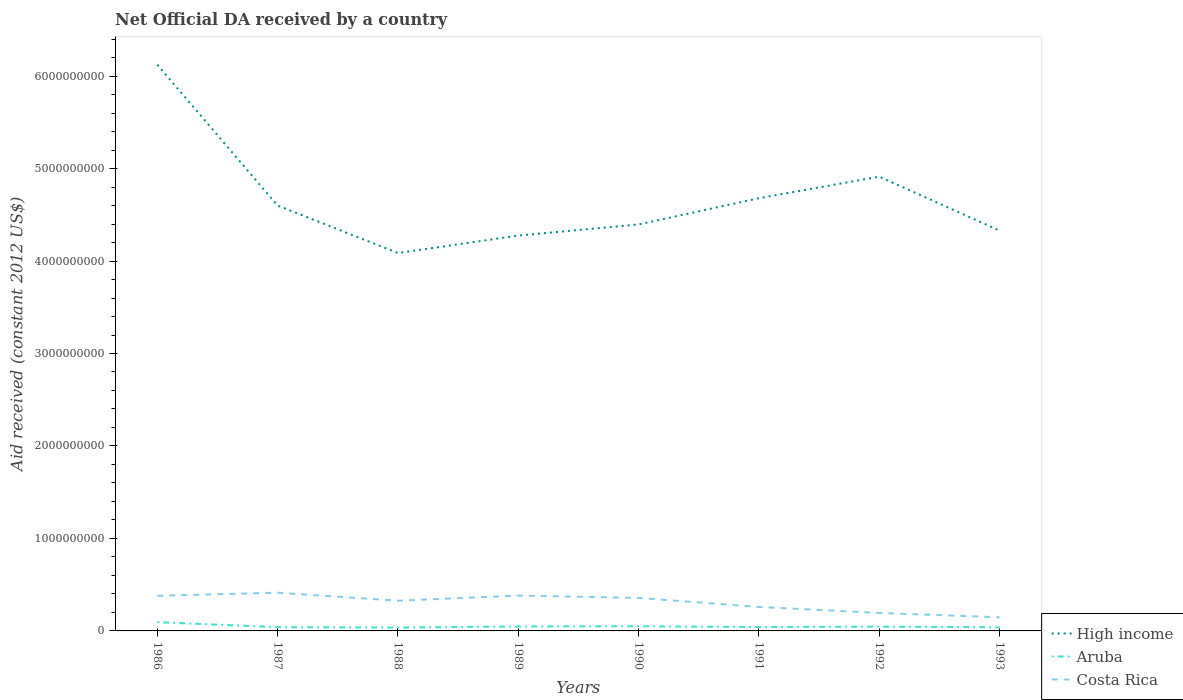Across all years, what is the maximum net official development assistance aid received in High income?
Your response must be concise. 4.09e+09. What is the total net official development assistance aid received in High income in the graph?
Give a very brief answer. 2.04e+09. What is the difference between the highest and the second highest net official development assistance aid received in Aruba?
Make the answer very short. 5.84e+07. What is the difference between the highest and the lowest net official development assistance aid received in Costa Rica?
Provide a succinct answer. 5. Is the net official development assistance aid received in Aruba strictly greater than the net official development assistance aid received in Costa Rica over the years?
Offer a terse response. Yes. How many years are there in the graph?
Ensure brevity in your answer.  8. Are the values on the major ticks of Y-axis written in scientific E-notation?
Your answer should be very brief. No. Does the graph contain any zero values?
Give a very brief answer. No. How many legend labels are there?
Offer a terse response. 3. How are the legend labels stacked?
Make the answer very short. Vertical. What is the title of the graph?
Your answer should be very brief. Net Official DA received by a country. Does "Oman" appear as one of the legend labels in the graph?
Keep it short and to the point. No. What is the label or title of the X-axis?
Make the answer very short. Years. What is the label or title of the Y-axis?
Offer a very short reply. Aid received (constant 2012 US$). What is the Aid received (constant 2012 US$) in High income in 1986?
Offer a terse response. 6.12e+09. What is the Aid received (constant 2012 US$) of Aruba in 1986?
Your answer should be very brief. 9.46e+07. What is the Aid received (constant 2012 US$) of Costa Rica in 1986?
Ensure brevity in your answer.  3.80e+08. What is the Aid received (constant 2012 US$) of High income in 1987?
Offer a terse response. 4.60e+09. What is the Aid received (constant 2012 US$) of Aruba in 1987?
Provide a short and direct response. 4.08e+07. What is the Aid received (constant 2012 US$) in Costa Rica in 1987?
Keep it short and to the point. 4.14e+08. What is the Aid received (constant 2012 US$) in High income in 1988?
Keep it short and to the point. 4.09e+09. What is the Aid received (constant 2012 US$) in Aruba in 1988?
Your answer should be compact. 3.62e+07. What is the Aid received (constant 2012 US$) in Costa Rica in 1988?
Your answer should be compact. 3.27e+08. What is the Aid received (constant 2012 US$) in High income in 1989?
Offer a terse response. 4.28e+09. What is the Aid received (constant 2012 US$) in Aruba in 1989?
Your answer should be compact. 4.83e+07. What is the Aid received (constant 2012 US$) in Costa Rica in 1989?
Your answer should be compact. 3.82e+08. What is the Aid received (constant 2012 US$) of High income in 1990?
Give a very brief answer. 4.40e+09. What is the Aid received (constant 2012 US$) in Aruba in 1990?
Your answer should be very brief. 5.03e+07. What is the Aid received (constant 2012 US$) of Costa Rica in 1990?
Your response must be concise. 3.57e+08. What is the Aid received (constant 2012 US$) in High income in 1991?
Keep it short and to the point. 4.68e+09. What is the Aid received (constant 2012 US$) in Aruba in 1991?
Offer a terse response. 4.18e+07. What is the Aid received (constant 2012 US$) of Costa Rica in 1991?
Your answer should be compact. 2.59e+08. What is the Aid received (constant 2012 US$) in High income in 1992?
Ensure brevity in your answer.  4.91e+09. What is the Aid received (constant 2012 US$) in Aruba in 1992?
Your response must be concise. 4.60e+07. What is the Aid received (constant 2012 US$) in Costa Rica in 1992?
Your response must be concise. 1.95e+08. What is the Aid received (constant 2012 US$) of High income in 1993?
Provide a succinct answer. 4.33e+09. What is the Aid received (constant 2012 US$) in Aruba in 1993?
Your response must be concise. 3.96e+07. What is the Aid received (constant 2012 US$) of Costa Rica in 1993?
Keep it short and to the point. 1.48e+08. Across all years, what is the maximum Aid received (constant 2012 US$) in High income?
Provide a short and direct response. 6.12e+09. Across all years, what is the maximum Aid received (constant 2012 US$) in Aruba?
Make the answer very short. 9.46e+07. Across all years, what is the maximum Aid received (constant 2012 US$) in Costa Rica?
Provide a succinct answer. 4.14e+08. Across all years, what is the minimum Aid received (constant 2012 US$) in High income?
Your answer should be compact. 4.09e+09. Across all years, what is the minimum Aid received (constant 2012 US$) in Aruba?
Offer a terse response. 3.62e+07. Across all years, what is the minimum Aid received (constant 2012 US$) in Costa Rica?
Make the answer very short. 1.48e+08. What is the total Aid received (constant 2012 US$) in High income in the graph?
Your answer should be compact. 3.74e+1. What is the total Aid received (constant 2012 US$) of Aruba in the graph?
Keep it short and to the point. 3.97e+08. What is the total Aid received (constant 2012 US$) in Costa Rica in the graph?
Your answer should be very brief. 2.46e+09. What is the difference between the Aid received (constant 2012 US$) in High income in 1986 and that in 1987?
Ensure brevity in your answer.  1.52e+09. What is the difference between the Aid received (constant 2012 US$) in Aruba in 1986 and that in 1987?
Your response must be concise. 5.39e+07. What is the difference between the Aid received (constant 2012 US$) of Costa Rica in 1986 and that in 1987?
Your answer should be compact. -3.40e+07. What is the difference between the Aid received (constant 2012 US$) of High income in 1986 and that in 1988?
Give a very brief answer. 2.04e+09. What is the difference between the Aid received (constant 2012 US$) in Aruba in 1986 and that in 1988?
Provide a short and direct response. 5.84e+07. What is the difference between the Aid received (constant 2012 US$) in Costa Rica in 1986 and that in 1988?
Your answer should be very brief. 5.31e+07. What is the difference between the Aid received (constant 2012 US$) in High income in 1986 and that in 1989?
Your response must be concise. 1.85e+09. What is the difference between the Aid received (constant 2012 US$) in Aruba in 1986 and that in 1989?
Your response must be concise. 4.63e+07. What is the difference between the Aid received (constant 2012 US$) of Costa Rica in 1986 and that in 1989?
Offer a very short reply. -2.80e+06. What is the difference between the Aid received (constant 2012 US$) in High income in 1986 and that in 1990?
Ensure brevity in your answer.  1.73e+09. What is the difference between the Aid received (constant 2012 US$) of Aruba in 1986 and that in 1990?
Keep it short and to the point. 4.43e+07. What is the difference between the Aid received (constant 2012 US$) in Costa Rica in 1986 and that in 1990?
Offer a very short reply. 2.28e+07. What is the difference between the Aid received (constant 2012 US$) in High income in 1986 and that in 1991?
Provide a short and direct response. 1.44e+09. What is the difference between the Aid received (constant 2012 US$) in Aruba in 1986 and that in 1991?
Give a very brief answer. 5.29e+07. What is the difference between the Aid received (constant 2012 US$) of Costa Rica in 1986 and that in 1991?
Ensure brevity in your answer.  1.21e+08. What is the difference between the Aid received (constant 2012 US$) in High income in 1986 and that in 1992?
Give a very brief answer. 1.21e+09. What is the difference between the Aid received (constant 2012 US$) of Aruba in 1986 and that in 1992?
Your answer should be compact. 4.86e+07. What is the difference between the Aid received (constant 2012 US$) of Costa Rica in 1986 and that in 1992?
Make the answer very short. 1.85e+08. What is the difference between the Aid received (constant 2012 US$) in High income in 1986 and that in 1993?
Provide a short and direct response. 1.79e+09. What is the difference between the Aid received (constant 2012 US$) in Aruba in 1986 and that in 1993?
Provide a succinct answer. 5.51e+07. What is the difference between the Aid received (constant 2012 US$) of Costa Rica in 1986 and that in 1993?
Provide a succinct answer. 2.32e+08. What is the difference between the Aid received (constant 2012 US$) of High income in 1987 and that in 1988?
Give a very brief answer. 5.14e+08. What is the difference between the Aid received (constant 2012 US$) in Aruba in 1987 and that in 1988?
Provide a succinct answer. 4.54e+06. What is the difference between the Aid received (constant 2012 US$) of Costa Rica in 1987 and that in 1988?
Your response must be concise. 8.71e+07. What is the difference between the Aid received (constant 2012 US$) of High income in 1987 and that in 1989?
Keep it short and to the point. 3.25e+08. What is the difference between the Aid received (constant 2012 US$) of Aruba in 1987 and that in 1989?
Offer a terse response. -7.56e+06. What is the difference between the Aid received (constant 2012 US$) of Costa Rica in 1987 and that in 1989?
Keep it short and to the point. 3.12e+07. What is the difference between the Aid received (constant 2012 US$) in High income in 1987 and that in 1990?
Keep it short and to the point. 2.04e+08. What is the difference between the Aid received (constant 2012 US$) in Aruba in 1987 and that in 1990?
Provide a short and direct response. -9.53e+06. What is the difference between the Aid received (constant 2012 US$) in Costa Rica in 1987 and that in 1990?
Make the answer very short. 5.68e+07. What is the difference between the Aid received (constant 2012 US$) of High income in 1987 and that in 1991?
Your response must be concise. -7.94e+07. What is the difference between the Aid received (constant 2012 US$) of Aruba in 1987 and that in 1991?
Offer a terse response. -1.01e+06. What is the difference between the Aid received (constant 2012 US$) of Costa Rica in 1987 and that in 1991?
Your answer should be very brief. 1.55e+08. What is the difference between the Aid received (constant 2012 US$) in High income in 1987 and that in 1992?
Give a very brief answer. -3.12e+08. What is the difference between the Aid received (constant 2012 US$) of Aruba in 1987 and that in 1992?
Keep it short and to the point. -5.25e+06. What is the difference between the Aid received (constant 2012 US$) of Costa Rica in 1987 and that in 1992?
Offer a terse response. 2.19e+08. What is the difference between the Aid received (constant 2012 US$) in High income in 1987 and that in 1993?
Provide a succinct answer. 2.70e+08. What is the difference between the Aid received (constant 2012 US$) in Aruba in 1987 and that in 1993?
Provide a short and direct response. 1.20e+06. What is the difference between the Aid received (constant 2012 US$) in Costa Rica in 1987 and that in 1993?
Make the answer very short. 2.66e+08. What is the difference between the Aid received (constant 2012 US$) in High income in 1988 and that in 1989?
Keep it short and to the point. -1.89e+08. What is the difference between the Aid received (constant 2012 US$) in Aruba in 1988 and that in 1989?
Ensure brevity in your answer.  -1.21e+07. What is the difference between the Aid received (constant 2012 US$) of Costa Rica in 1988 and that in 1989?
Provide a succinct answer. -5.59e+07. What is the difference between the Aid received (constant 2012 US$) of High income in 1988 and that in 1990?
Ensure brevity in your answer.  -3.09e+08. What is the difference between the Aid received (constant 2012 US$) of Aruba in 1988 and that in 1990?
Give a very brief answer. -1.41e+07. What is the difference between the Aid received (constant 2012 US$) in Costa Rica in 1988 and that in 1990?
Your answer should be very brief. -3.03e+07. What is the difference between the Aid received (constant 2012 US$) in High income in 1988 and that in 1991?
Offer a very short reply. -5.93e+08. What is the difference between the Aid received (constant 2012 US$) of Aruba in 1988 and that in 1991?
Keep it short and to the point. -5.55e+06. What is the difference between the Aid received (constant 2012 US$) in Costa Rica in 1988 and that in 1991?
Offer a terse response. 6.74e+07. What is the difference between the Aid received (constant 2012 US$) in High income in 1988 and that in 1992?
Ensure brevity in your answer.  -8.26e+08. What is the difference between the Aid received (constant 2012 US$) of Aruba in 1988 and that in 1992?
Give a very brief answer. -9.79e+06. What is the difference between the Aid received (constant 2012 US$) of Costa Rica in 1988 and that in 1992?
Your answer should be very brief. 1.32e+08. What is the difference between the Aid received (constant 2012 US$) of High income in 1988 and that in 1993?
Make the answer very short. -2.43e+08. What is the difference between the Aid received (constant 2012 US$) of Aruba in 1988 and that in 1993?
Your answer should be compact. -3.34e+06. What is the difference between the Aid received (constant 2012 US$) of Costa Rica in 1988 and that in 1993?
Provide a short and direct response. 1.79e+08. What is the difference between the Aid received (constant 2012 US$) in High income in 1989 and that in 1990?
Your response must be concise. -1.20e+08. What is the difference between the Aid received (constant 2012 US$) of Aruba in 1989 and that in 1990?
Give a very brief answer. -1.97e+06. What is the difference between the Aid received (constant 2012 US$) of Costa Rica in 1989 and that in 1990?
Offer a terse response. 2.56e+07. What is the difference between the Aid received (constant 2012 US$) of High income in 1989 and that in 1991?
Keep it short and to the point. -4.04e+08. What is the difference between the Aid received (constant 2012 US$) of Aruba in 1989 and that in 1991?
Your answer should be very brief. 6.55e+06. What is the difference between the Aid received (constant 2012 US$) in Costa Rica in 1989 and that in 1991?
Keep it short and to the point. 1.23e+08. What is the difference between the Aid received (constant 2012 US$) of High income in 1989 and that in 1992?
Ensure brevity in your answer.  -6.37e+08. What is the difference between the Aid received (constant 2012 US$) in Aruba in 1989 and that in 1992?
Keep it short and to the point. 2.31e+06. What is the difference between the Aid received (constant 2012 US$) of Costa Rica in 1989 and that in 1992?
Offer a very short reply. 1.88e+08. What is the difference between the Aid received (constant 2012 US$) in High income in 1989 and that in 1993?
Offer a very short reply. -5.44e+07. What is the difference between the Aid received (constant 2012 US$) in Aruba in 1989 and that in 1993?
Your answer should be very brief. 8.76e+06. What is the difference between the Aid received (constant 2012 US$) in Costa Rica in 1989 and that in 1993?
Offer a very short reply. 2.35e+08. What is the difference between the Aid received (constant 2012 US$) in High income in 1990 and that in 1991?
Give a very brief answer. -2.84e+08. What is the difference between the Aid received (constant 2012 US$) of Aruba in 1990 and that in 1991?
Your answer should be compact. 8.52e+06. What is the difference between the Aid received (constant 2012 US$) in Costa Rica in 1990 and that in 1991?
Your response must be concise. 9.77e+07. What is the difference between the Aid received (constant 2012 US$) in High income in 1990 and that in 1992?
Your answer should be very brief. -5.17e+08. What is the difference between the Aid received (constant 2012 US$) of Aruba in 1990 and that in 1992?
Give a very brief answer. 4.28e+06. What is the difference between the Aid received (constant 2012 US$) of Costa Rica in 1990 and that in 1992?
Ensure brevity in your answer.  1.62e+08. What is the difference between the Aid received (constant 2012 US$) in High income in 1990 and that in 1993?
Your answer should be compact. 6.60e+07. What is the difference between the Aid received (constant 2012 US$) of Aruba in 1990 and that in 1993?
Provide a short and direct response. 1.07e+07. What is the difference between the Aid received (constant 2012 US$) of Costa Rica in 1990 and that in 1993?
Your response must be concise. 2.09e+08. What is the difference between the Aid received (constant 2012 US$) in High income in 1991 and that in 1992?
Provide a short and direct response. -2.33e+08. What is the difference between the Aid received (constant 2012 US$) in Aruba in 1991 and that in 1992?
Offer a very short reply. -4.24e+06. What is the difference between the Aid received (constant 2012 US$) in Costa Rica in 1991 and that in 1992?
Ensure brevity in your answer.  6.46e+07. What is the difference between the Aid received (constant 2012 US$) of High income in 1991 and that in 1993?
Offer a very short reply. 3.50e+08. What is the difference between the Aid received (constant 2012 US$) of Aruba in 1991 and that in 1993?
Your answer should be compact. 2.21e+06. What is the difference between the Aid received (constant 2012 US$) of Costa Rica in 1991 and that in 1993?
Provide a short and direct response. 1.12e+08. What is the difference between the Aid received (constant 2012 US$) in High income in 1992 and that in 1993?
Your response must be concise. 5.83e+08. What is the difference between the Aid received (constant 2012 US$) of Aruba in 1992 and that in 1993?
Ensure brevity in your answer.  6.45e+06. What is the difference between the Aid received (constant 2012 US$) of Costa Rica in 1992 and that in 1993?
Ensure brevity in your answer.  4.70e+07. What is the difference between the Aid received (constant 2012 US$) in High income in 1986 and the Aid received (constant 2012 US$) in Aruba in 1987?
Your answer should be compact. 6.08e+09. What is the difference between the Aid received (constant 2012 US$) of High income in 1986 and the Aid received (constant 2012 US$) of Costa Rica in 1987?
Keep it short and to the point. 5.71e+09. What is the difference between the Aid received (constant 2012 US$) in Aruba in 1986 and the Aid received (constant 2012 US$) in Costa Rica in 1987?
Your response must be concise. -3.19e+08. What is the difference between the Aid received (constant 2012 US$) in High income in 1986 and the Aid received (constant 2012 US$) in Aruba in 1988?
Give a very brief answer. 6.09e+09. What is the difference between the Aid received (constant 2012 US$) in High income in 1986 and the Aid received (constant 2012 US$) in Costa Rica in 1988?
Ensure brevity in your answer.  5.80e+09. What is the difference between the Aid received (constant 2012 US$) of Aruba in 1986 and the Aid received (constant 2012 US$) of Costa Rica in 1988?
Offer a terse response. -2.32e+08. What is the difference between the Aid received (constant 2012 US$) in High income in 1986 and the Aid received (constant 2012 US$) in Aruba in 1989?
Provide a short and direct response. 6.07e+09. What is the difference between the Aid received (constant 2012 US$) in High income in 1986 and the Aid received (constant 2012 US$) in Costa Rica in 1989?
Ensure brevity in your answer.  5.74e+09. What is the difference between the Aid received (constant 2012 US$) in Aruba in 1986 and the Aid received (constant 2012 US$) in Costa Rica in 1989?
Offer a very short reply. -2.88e+08. What is the difference between the Aid received (constant 2012 US$) of High income in 1986 and the Aid received (constant 2012 US$) of Aruba in 1990?
Your response must be concise. 6.07e+09. What is the difference between the Aid received (constant 2012 US$) of High income in 1986 and the Aid received (constant 2012 US$) of Costa Rica in 1990?
Your answer should be compact. 5.77e+09. What is the difference between the Aid received (constant 2012 US$) in Aruba in 1986 and the Aid received (constant 2012 US$) in Costa Rica in 1990?
Your response must be concise. -2.62e+08. What is the difference between the Aid received (constant 2012 US$) in High income in 1986 and the Aid received (constant 2012 US$) in Aruba in 1991?
Make the answer very short. 6.08e+09. What is the difference between the Aid received (constant 2012 US$) of High income in 1986 and the Aid received (constant 2012 US$) of Costa Rica in 1991?
Give a very brief answer. 5.86e+09. What is the difference between the Aid received (constant 2012 US$) of Aruba in 1986 and the Aid received (constant 2012 US$) of Costa Rica in 1991?
Provide a short and direct response. -1.64e+08. What is the difference between the Aid received (constant 2012 US$) in High income in 1986 and the Aid received (constant 2012 US$) in Aruba in 1992?
Your answer should be very brief. 6.08e+09. What is the difference between the Aid received (constant 2012 US$) in High income in 1986 and the Aid received (constant 2012 US$) in Costa Rica in 1992?
Provide a short and direct response. 5.93e+09. What is the difference between the Aid received (constant 2012 US$) of Aruba in 1986 and the Aid received (constant 2012 US$) of Costa Rica in 1992?
Offer a very short reply. -9.99e+07. What is the difference between the Aid received (constant 2012 US$) in High income in 1986 and the Aid received (constant 2012 US$) in Aruba in 1993?
Your answer should be compact. 6.08e+09. What is the difference between the Aid received (constant 2012 US$) of High income in 1986 and the Aid received (constant 2012 US$) of Costa Rica in 1993?
Your response must be concise. 5.98e+09. What is the difference between the Aid received (constant 2012 US$) of Aruba in 1986 and the Aid received (constant 2012 US$) of Costa Rica in 1993?
Provide a short and direct response. -5.29e+07. What is the difference between the Aid received (constant 2012 US$) of High income in 1987 and the Aid received (constant 2012 US$) of Aruba in 1988?
Make the answer very short. 4.56e+09. What is the difference between the Aid received (constant 2012 US$) of High income in 1987 and the Aid received (constant 2012 US$) of Costa Rica in 1988?
Your response must be concise. 4.27e+09. What is the difference between the Aid received (constant 2012 US$) of Aruba in 1987 and the Aid received (constant 2012 US$) of Costa Rica in 1988?
Your response must be concise. -2.86e+08. What is the difference between the Aid received (constant 2012 US$) in High income in 1987 and the Aid received (constant 2012 US$) in Aruba in 1989?
Provide a succinct answer. 4.55e+09. What is the difference between the Aid received (constant 2012 US$) of High income in 1987 and the Aid received (constant 2012 US$) of Costa Rica in 1989?
Offer a terse response. 4.22e+09. What is the difference between the Aid received (constant 2012 US$) in Aruba in 1987 and the Aid received (constant 2012 US$) in Costa Rica in 1989?
Offer a very short reply. -3.42e+08. What is the difference between the Aid received (constant 2012 US$) of High income in 1987 and the Aid received (constant 2012 US$) of Aruba in 1990?
Provide a short and direct response. 4.55e+09. What is the difference between the Aid received (constant 2012 US$) in High income in 1987 and the Aid received (constant 2012 US$) in Costa Rica in 1990?
Ensure brevity in your answer.  4.24e+09. What is the difference between the Aid received (constant 2012 US$) in Aruba in 1987 and the Aid received (constant 2012 US$) in Costa Rica in 1990?
Keep it short and to the point. -3.16e+08. What is the difference between the Aid received (constant 2012 US$) of High income in 1987 and the Aid received (constant 2012 US$) of Aruba in 1991?
Ensure brevity in your answer.  4.56e+09. What is the difference between the Aid received (constant 2012 US$) of High income in 1987 and the Aid received (constant 2012 US$) of Costa Rica in 1991?
Your response must be concise. 4.34e+09. What is the difference between the Aid received (constant 2012 US$) in Aruba in 1987 and the Aid received (constant 2012 US$) in Costa Rica in 1991?
Ensure brevity in your answer.  -2.18e+08. What is the difference between the Aid received (constant 2012 US$) in High income in 1987 and the Aid received (constant 2012 US$) in Aruba in 1992?
Provide a short and direct response. 4.55e+09. What is the difference between the Aid received (constant 2012 US$) in High income in 1987 and the Aid received (constant 2012 US$) in Costa Rica in 1992?
Your response must be concise. 4.41e+09. What is the difference between the Aid received (constant 2012 US$) of Aruba in 1987 and the Aid received (constant 2012 US$) of Costa Rica in 1992?
Your response must be concise. -1.54e+08. What is the difference between the Aid received (constant 2012 US$) of High income in 1987 and the Aid received (constant 2012 US$) of Aruba in 1993?
Provide a short and direct response. 4.56e+09. What is the difference between the Aid received (constant 2012 US$) in High income in 1987 and the Aid received (constant 2012 US$) in Costa Rica in 1993?
Offer a terse response. 4.45e+09. What is the difference between the Aid received (constant 2012 US$) in Aruba in 1987 and the Aid received (constant 2012 US$) in Costa Rica in 1993?
Provide a succinct answer. -1.07e+08. What is the difference between the Aid received (constant 2012 US$) in High income in 1988 and the Aid received (constant 2012 US$) in Aruba in 1989?
Offer a terse response. 4.04e+09. What is the difference between the Aid received (constant 2012 US$) of High income in 1988 and the Aid received (constant 2012 US$) of Costa Rica in 1989?
Make the answer very short. 3.70e+09. What is the difference between the Aid received (constant 2012 US$) of Aruba in 1988 and the Aid received (constant 2012 US$) of Costa Rica in 1989?
Your answer should be very brief. -3.46e+08. What is the difference between the Aid received (constant 2012 US$) of High income in 1988 and the Aid received (constant 2012 US$) of Aruba in 1990?
Make the answer very short. 4.04e+09. What is the difference between the Aid received (constant 2012 US$) of High income in 1988 and the Aid received (constant 2012 US$) of Costa Rica in 1990?
Provide a short and direct response. 3.73e+09. What is the difference between the Aid received (constant 2012 US$) in Aruba in 1988 and the Aid received (constant 2012 US$) in Costa Rica in 1990?
Your response must be concise. -3.21e+08. What is the difference between the Aid received (constant 2012 US$) in High income in 1988 and the Aid received (constant 2012 US$) in Aruba in 1991?
Provide a succinct answer. 4.04e+09. What is the difference between the Aid received (constant 2012 US$) of High income in 1988 and the Aid received (constant 2012 US$) of Costa Rica in 1991?
Provide a short and direct response. 3.83e+09. What is the difference between the Aid received (constant 2012 US$) in Aruba in 1988 and the Aid received (constant 2012 US$) in Costa Rica in 1991?
Provide a succinct answer. -2.23e+08. What is the difference between the Aid received (constant 2012 US$) in High income in 1988 and the Aid received (constant 2012 US$) in Aruba in 1992?
Make the answer very short. 4.04e+09. What is the difference between the Aid received (constant 2012 US$) in High income in 1988 and the Aid received (constant 2012 US$) in Costa Rica in 1992?
Offer a very short reply. 3.89e+09. What is the difference between the Aid received (constant 2012 US$) in Aruba in 1988 and the Aid received (constant 2012 US$) in Costa Rica in 1992?
Your response must be concise. -1.58e+08. What is the difference between the Aid received (constant 2012 US$) in High income in 1988 and the Aid received (constant 2012 US$) in Aruba in 1993?
Offer a very short reply. 4.05e+09. What is the difference between the Aid received (constant 2012 US$) in High income in 1988 and the Aid received (constant 2012 US$) in Costa Rica in 1993?
Keep it short and to the point. 3.94e+09. What is the difference between the Aid received (constant 2012 US$) in Aruba in 1988 and the Aid received (constant 2012 US$) in Costa Rica in 1993?
Your answer should be compact. -1.11e+08. What is the difference between the Aid received (constant 2012 US$) of High income in 1989 and the Aid received (constant 2012 US$) of Aruba in 1990?
Offer a terse response. 4.22e+09. What is the difference between the Aid received (constant 2012 US$) in High income in 1989 and the Aid received (constant 2012 US$) in Costa Rica in 1990?
Your response must be concise. 3.92e+09. What is the difference between the Aid received (constant 2012 US$) in Aruba in 1989 and the Aid received (constant 2012 US$) in Costa Rica in 1990?
Provide a short and direct response. -3.09e+08. What is the difference between the Aid received (constant 2012 US$) in High income in 1989 and the Aid received (constant 2012 US$) in Aruba in 1991?
Your answer should be compact. 4.23e+09. What is the difference between the Aid received (constant 2012 US$) in High income in 1989 and the Aid received (constant 2012 US$) in Costa Rica in 1991?
Keep it short and to the point. 4.02e+09. What is the difference between the Aid received (constant 2012 US$) in Aruba in 1989 and the Aid received (constant 2012 US$) in Costa Rica in 1991?
Make the answer very short. -2.11e+08. What is the difference between the Aid received (constant 2012 US$) of High income in 1989 and the Aid received (constant 2012 US$) of Aruba in 1992?
Offer a terse response. 4.23e+09. What is the difference between the Aid received (constant 2012 US$) in High income in 1989 and the Aid received (constant 2012 US$) in Costa Rica in 1992?
Your answer should be compact. 4.08e+09. What is the difference between the Aid received (constant 2012 US$) of Aruba in 1989 and the Aid received (constant 2012 US$) of Costa Rica in 1992?
Your answer should be very brief. -1.46e+08. What is the difference between the Aid received (constant 2012 US$) in High income in 1989 and the Aid received (constant 2012 US$) in Aruba in 1993?
Ensure brevity in your answer.  4.24e+09. What is the difference between the Aid received (constant 2012 US$) of High income in 1989 and the Aid received (constant 2012 US$) of Costa Rica in 1993?
Your answer should be very brief. 4.13e+09. What is the difference between the Aid received (constant 2012 US$) of Aruba in 1989 and the Aid received (constant 2012 US$) of Costa Rica in 1993?
Keep it short and to the point. -9.92e+07. What is the difference between the Aid received (constant 2012 US$) in High income in 1990 and the Aid received (constant 2012 US$) in Aruba in 1991?
Offer a terse response. 4.35e+09. What is the difference between the Aid received (constant 2012 US$) of High income in 1990 and the Aid received (constant 2012 US$) of Costa Rica in 1991?
Your response must be concise. 4.14e+09. What is the difference between the Aid received (constant 2012 US$) in Aruba in 1990 and the Aid received (constant 2012 US$) in Costa Rica in 1991?
Your answer should be compact. -2.09e+08. What is the difference between the Aid received (constant 2012 US$) of High income in 1990 and the Aid received (constant 2012 US$) of Aruba in 1992?
Your answer should be very brief. 4.35e+09. What is the difference between the Aid received (constant 2012 US$) of High income in 1990 and the Aid received (constant 2012 US$) of Costa Rica in 1992?
Offer a very short reply. 4.20e+09. What is the difference between the Aid received (constant 2012 US$) in Aruba in 1990 and the Aid received (constant 2012 US$) in Costa Rica in 1992?
Your answer should be compact. -1.44e+08. What is the difference between the Aid received (constant 2012 US$) in High income in 1990 and the Aid received (constant 2012 US$) in Aruba in 1993?
Your answer should be compact. 4.36e+09. What is the difference between the Aid received (constant 2012 US$) in High income in 1990 and the Aid received (constant 2012 US$) in Costa Rica in 1993?
Your answer should be very brief. 4.25e+09. What is the difference between the Aid received (constant 2012 US$) in Aruba in 1990 and the Aid received (constant 2012 US$) in Costa Rica in 1993?
Provide a succinct answer. -9.73e+07. What is the difference between the Aid received (constant 2012 US$) in High income in 1991 and the Aid received (constant 2012 US$) in Aruba in 1992?
Make the answer very short. 4.63e+09. What is the difference between the Aid received (constant 2012 US$) in High income in 1991 and the Aid received (constant 2012 US$) in Costa Rica in 1992?
Keep it short and to the point. 4.48e+09. What is the difference between the Aid received (constant 2012 US$) of Aruba in 1991 and the Aid received (constant 2012 US$) of Costa Rica in 1992?
Make the answer very short. -1.53e+08. What is the difference between the Aid received (constant 2012 US$) of High income in 1991 and the Aid received (constant 2012 US$) of Aruba in 1993?
Keep it short and to the point. 4.64e+09. What is the difference between the Aid received (constant 2012 US$) of High income in 1991 and the Aid received (constant 2012 US$) of Costa Rica in 1993?
Offer a terse response. 4.53e+09. What is the difference between the Aid received (constant 2012 US$) in Aruba in 1991 and the Aid received (constant 2012 US$) in Costa Rica in 1993?
Keep it short and to the point. -1.06e+08. What is the difference between the Aid received (constant 2012 US$) of High income in 1992 and the Aid received (constant 2012 US$) of Aruba in 1993?
Offer a very short reply. 4.87e+09. What is the difference between the Aid received (constant 2012 US$) of High income in 1992 and the Aid received (constant 2012 US$) of Costa Rica in 1993?
Your answer should be very brief. 4.76e+09. What is the difference between the Aid received (constant 2012 US$) in Aruba in 1992 and the Aid received (constant 2012 US$) in Costa Rica in 1993?
Your answer should be very brief. -1.02e+08. What is the average Aid received (constant 2012 US$) in High income per year?
Ensure brevity in your answer.  4.68e+09. What is the average Aid received (constant 2012 US$) in Aruba per year?
Provide a short and direct response. 4.97e+07. What is the average Aid received (constant 2012 US$) of Costa Rica per year?
Make the answer very short. 3.08e+08. In the year 1986, what is the difference between the Aid received (constant 2012 US$) of High income and Aid received (constant 2012 US$) of Aruba?
Your answer should be compact. 6.03e+09. In the year 1986, what is the difference between the Aid received (constant 2012 US$) of High income and Aid received (constant 2012 US$) of Costa Rica?
Provide a short and direct response. 5.74e+09. In the year 1986, what is the difference between the Aid received (constant 2012 US$) in Aruba and Aid received (constant 2012 US$) in Costa Rica?
Ensure brevity in your answer.  -2.85e+08. In the year 1987, what is the difference between the Aid received (constant 2012 US$) of High income and Aid received (constant 2012 US$) of Aruba?
Provide a succinct answer. 4.56e+09. In the year 1987, what is the difference between the Aid received (constant 2012 US$) in High income and Aid received (constant 2012 US$) in Costa Rica?
Give a very brief answer. 4.19e+09. In the year 1987, what is the difference between the Aid received (constant 2012 US$) of Aruba and Aid received (constant 2012 US$) of Costa Rica?
Provide a succinct answer. -3.73e+08. In the year 1988, what is the difference between the Aid received (constant 2012 US$) of High income and Aid received (constant 2012 US$) of Aruba?
Provide a short and direct response. 4.05e+09. In the year 1988, what is the difference between the Aid received (constant 2012 US$) in High income and Aid received (constant 2012 US$) in Costa Rica?
Provide a short and direct response. 3.76e+09. In the year 1988, what is the difference between the Aid received (constant 2012 US$) of Aruba and Aid received (constant 2012 US$) of Costa Rica?
Your answer should be very brief. -2.90e+08. In the year 1989, what is the difference between the Aid received (constant 2012 US$) of High income and Aid received (constant 2012 US$) of Aruba?
Offer a very short reply. 4.23e+09. In the year 1989, what is the difference between the Aid received (constant 2012 US$) of High income and Aid received (constant 2012 US$) of Costa Rica?
Provide a short and direct response. 3.89e+09. In the year 1989, what is the difference between the Aid received (constant 2012 US$) in Aruba and Aid received (constant 2012 US$) in Costa Rica?
Provide a short and direct response. -3.34e+08. In the year 1990, what is the difference between the Aid received (constant 2012 US$) of High income and Aid received (constant 2012 US$) of Aruba?
Offer a very short reply. 4.35e+09. In the year 1990, what is the difference between the Aid received (constant 2012 US$) in High income and Aid received (constant 2012 US$) in Costa Rica?
Give a very brief answer. 4.04e+09. In the year 1990, what is the difference between the Aid received (constant 2012 US$) of Aruba and Aid received (constant 2012 US$) of Costa Rica?
Ensure brevity in your answer.  -3.07e+08. In the year 1991, what is the difference between the Aid received (constant 2012 US$) in High income and Aid received (constant 2012 US$) in Aruba?
Provide a succinct answer. 4.64e+09. In the year 1991, what is the difference between the Aid received (constant 2012 US$) in High income and Aid received (constant 2012 US$) in Costa Rica?
Offer a terse response. 4.42e+09. In the year 1991, what is the difference between the Aid received (constant 2012 US$) in Aruba and Aid received (constant 2012 US$) in Costa Rica?
Give a very brief answer. -2.17e+08. In the year 1992, what is the difference between the Aid received (constant 2012 US$) of High income and Aid received (constant 2012 US$) of Aruba?
Offer a terse response. 4.87e+09. In the year 1992, what is the difference between the Aid received (constant 2012 US$) of High income and Aid received (constant 2012 US$) of Costa Rica?
Provide a short and direct response. 4.72e+09. In the year 1992, what is the difference between the Aid received (constant 2012 US$) in Aruba and Aid received (constant 2012 US$) in Costa Rica?
Offer a very short reply. -1.49e+08. In the year 1993, what is the difference between the Aid received (constant 2012 US$) in High income and Aid received (constant 2012 US$) in Aruba?
Keep it short and to the point. 4.29e+09. In the year 1993, what is the difference between the Aid received (constant 2012 US$) of High income and Aid received (constant 2012 US$) of Costa Rica?
Offer a terse response. 4.18e+09. In the year 1993, what is the difference between the Aid received (constant 2012 US$) in Aruba and Aid received (constant 2012 US$) in Costa Rica?
Make the answer very short. -1.08e+08. What is the ratio of the Aid received (constant 2012 US$) of High income in 1986 to that in 1987?
Your response must be concise. 1.33. What is the ratio of the Aid received (constant 2012 US$) of Aruba in 1986 to that in 1987?
Your answer should be very brief. 2.32. What is the ratio of the Aid received (constant 2012 US$) of Costa Rica in 1986 to that in 1987?
Ensure brevity in your answer.  0.92. What is the ratio of the Aid received (constant 2012 US$) in High income in 1986 to that in 1988?
Your answer should be compact. 1.5. What is the ratio of the Aid received (constant 2012 US$) in Aruba in 1986 to that in 1988?
Keep it short and to the point. 2.61. What is the ratio of the Aid received (constant 2012 US$) in Costa Rica in 1986 to that in 1988?
Keep it short and to the point. 1.16. What is the ratio of the Aid received (constant 2012 US$) in High income in 1986 to that in 1989?
Ensure brevity in your answer.  1.43. What is the ratio of the Aid received (constant 2012 US$) of Aruba in 1986 to that in 1989?
Provide a succinct answer. 1.96. What is the ratio of the Aid received (constant 2012 US$) of Costa Rica in 1986 to that in 1989?
Your response must be concise. 0.99. What is the ratio of the Aid received (constant 2012 US$) in High income in 1986 to that in 1990?
Provide a succinct answer. 1.39. What is the ratio of the Aid received (constant 2012 US$) of Aruba in 1986 to that in 1990?
Keep it short and to the point. 1.88. What is the ratio of the Aid received (constant 2012 US$) of Costa Rica in 1986 to that in 1990?
Your response must be concise. 1.06. What is the ratio of the Aid received (constant 2012 US$) in High income in 1986 to that in 1991?
Ensure brevity in your answer.  1.31. What is the ratio of the Aid received (constant 2012 US$) in Aruba in 1986 to that in 1991?
Offer a terse response. 2.27. What is the ratio of the Aid received (constant 2012 US$) in Costa Rica in 1986 to that in 1991?
Offer a terse response. 1.47. What is the ratio of the Aid received (constant 2012 US$) in High income in 1986 to that in 1992?
Make the answer very short. 1.25. What is the ratio of the Aid received (constant 2012 US$) of Aruba in 1986 to that in 1992?
Provide a succinct answer. 2.06. What is the ratio of the Aid received (constant 2012 US$) of Costa Rica in 1986 to that in 1992?
Offer a terse response. 1.95. What is the ratio of the Aid received (constant 2012 US$) in High income in 1986 to that in 1993?
Provide a short and direct response. 1.41. What is the ratio of the Aid received (constant 2012 US$) of Aruba in 1986 to that in 1993?
Give a very brief answer. 2.39. What is the ratio of the Aid received (constant 2012 US$) in Costa Rica in 1986 to that in 1993?
Keep it short and to the point. 2.57. What is the ratio of the Aid received (constant 2012 US$) of High income in 1987 to that in 1988?
Provide a short and direct response. 1.13. What is the ratio of the Aid received (constant 2012 US$) of Aruba in 1987 to that in 1988?
Ensure brevity in your answer.  1.13. What is the ratio of the Aid received (constant 2012 US$) in Costa Rica in 1987 to that in 1988?
Your response must be concise. 1.27. What is the ratio of the Aid received (constant 2012 US$) of High income in 1987 to that in 1989?
Make the answer very short. 1.08. What is the ratio of the Aid received (constant 2012 US$) in Aruba in 1987 to that in 1989?
Your answer should be very brief. 0.84. What is the ratio of the Aid received (constant 2012 US$) in Costa Rica in 1987 to that in 1989?
Ensure brevity in your answer.  1.08. What is the ratio of the Aid received (constant 2012 US$) of High income in 1987 to that in 1990?
Provide a short and direct response. 1.05. What is the ratio of the Aid received (constant 2012 US$) of Aruba in 1987 to that in 1990?
Provide a short and direct response. 0.81. What is the ratio of the Aid received (constant 2012 US$) in Costa Rica in 1987 to that in 1990?
Provide a short and direct response. 1.16. What is the ratio of the Aid received (constant 2012 US$) in High income in 1987 to that in 1991?
Provide a succinct answer. 0.98. What is the ratio of the Aid received (constant 2012 US$) in Aruba in 1987 to that in 1991?
Your response must be concise. 0.98. What is the ratio of the Aid received (constant 2012 US$) in Costa Rica in 1987 to that in 1991?
Give a very brief answer. 1.6. What is the ratio of the Aid received (constant 2012 US$) in High income in 1987 to that in 1992?
Your answer should be compact. 0.94. What is the ratio of the Aid received (constant 2012 US$) of Aruba in 1987 to that in 1992?
Your answer should be compact. 0.89. What is the ratio of the Aid received (constant 2012 US$) of Costa Rica in 1987 to that in 1992?
Your answer should be very brief. 2.13. What is the ratio of the Aid received (constant 2012 US$) of Aruba in 1987 to that in 1993?
Provide a succinct answer. 1.03. What is the ratio of the Aid received (constant 2012 US$) of Costa Rica in 1987 to that in 1993?
Keep it short and to the point. 2.8. What is the ratio of the Aid received (constant 2012 US$) in High income in 1988 to that in 1989?
Keep it short and to the point. 0.96. What is the ratio of the Aid received (constant 2012 US$) in Aruba in 1988 to that in 1989?
Ensure brevity in your answer.  0.75. What is the ratio of the Aid received (constant 2012 US$) of Costa Rica in 1988 to that in 1989?
Make the answer very short. 0.85. What is the ratio of the Aid received (constant 2012 US$) in High income in 1988 to that in 1990?
Give a very brief answer. 0.93. What is the ratio of the Aid received (constant 2012 US$) of Aruba in 1988 to that in 1990?
Your answer should be compact. 0.72. What is the ratio of the Aid received (constant 2012 US$) of Costa Rica in 1988 to that in 1990?
Your response must be concise. 0.92. What is the ratio of the Aid received (constant 2012 US$) in High income in 1988 to that in 1991?
Your response must be concise. 0.87. What is the ratio of the Aid received (constant 2012 US$) of Aruba in 1988 to that in 1991?
Ensure brevity in your answer.  0.87. What is the ratio of the Aid received (constant 2012 US$) in Costa Rica in 1988 to that in 1991?
Make the answer very short. 1.26. What is the ratio of the Aid received (constant 2012 US$) of High income in 1988 to that in 1992?
Keep it short and to the point. 0.83. What is the ratio of the Aid received (constant 2012 US$) in Aruba in 1988 to that in 1992?
Provide a short and direct response. 0.79. What is the ratio of the Aid received (constant 2012 US$) of Costa Rica in 1988 to that in 1992?
Ensure brevity in your answer.  1.68. What is the ratio of the Aid received (constant 2012 US$) of High income in 1988 to that in 1993?
Provide a short and direct response. 0.94. What is the ratio of the Aid received (constant 2012 US$) of Aruba in 1988 to that in 1993?
Offer a terse response. 0.92. What is the ratio of the Aid received (constant 2012 US$) of Costa Rica in 1988 to that in 1993?
Your answer should be compact. 2.21. What is the ratio of the Aid received (constant 2012 US$) of High income in 1989 to that in 1990?
Give a very brief answer. 0.97. What is the ratio of the Aid received (constant 2012 US$) in Aruba in 1989 to that in 1990?
Your answer should be compact. 0.96. What is the ratio of the Aid received (constant 2012 US$) in Costa Rica in 1989 to that in 1990?
Your answer should be very brief. 1.07. What is the ratio of the Aid received (constant 2012 US$) of High income in 1989 to that in 1991?
Provide a succinct answer. 0.91. What is the ratio of the Aid received (constant 2012 US$) of Aruba in 1989 to that in 1991?
Provide a succinct answer. 1.16. What is the ratio of the Aid received (constant 2012 US$) in Costa Rica in 1989 to that in 1991?
Your answer should be very brief. 1.48. What is the ratio of the Aid received (constant 2012 US$) in High income in 1989 to that in 1992?
Offer a very short reply. 0.87. What is the ratio of the Aid received (constant 2012 US$) of Aruba in 1989 to that in 1992?
Provide a short and direct response. 1.05. What is the ratio of the Aid received (constant 2012 US$) of Costa Rica in 1989 to that in 1992?
Ensure brevity in your answer.  1.97. What is the ratio of the Aid received (constant 2012 US$) in High income in 1989 to that in 1993?
Keep it short and to the point. 0.99. What is the ratio of the Aid received (constant 2012 US$) in Aruba in 1989 to that in 1993?
Provide a short and direct response. 1.22. What is the ratio of the Aid received (constant 2012 US$) of Costa Rica in 1989 to that in 1993?
Keep it short and to the point. 2.59. What is the ratio of the Aid received (constant 2012 US$) in High income in 1990 to that in 1991?
Offer a very short reply. 0.94. What is the ratio of the Aid received (constant 2012 US$) in Aruba in 1990 to that in 1991?
Provide a succinct answer. 1.2. What is the ratio of the Aid received (constant 2012 US$) of Costa Rica in 1990 to that in 1991?
Provide a succinct answer. 1.38. What is the ratio of the Aid received (constant 2012 US$) of High income in 1990 to that in 1992?
Offer a very short reply. 0.89. What is the ratio of the Aid received (constant 2012 US$) of Aruba in 1990 to that in 1992?
Make the answer very short. 1.09. What is the ratio of the Aid received (constant 2012 US$) of Costa Rica in 1990 to that in 1992?
Your answer should be compact. 1.83. What is the ratio of the Aid received (constant 2012 US$) of High income in 1990 to that in 1993?
Offer a very short reply. 1.02. What is the ratio of the Aid received (constant 2012 US$) of Aruba in 1990 to that in 1993?
Your response must be concise. 1.27. What is the ratio of the Aid received (constant 2012 US$) of Costa Rica in 1990 to that in 1993?
Keep it short and to the point. 2.42. What is the ratio of the Aid received (constant 2012 US$) of High income in 1991 to that in 1992?
Provide a short and direct response. 0.95. What is the ratio of the Aid received (constant 2012 US$) of Aruba in 1991 to that in 1992?
Make the answer very short. 0.91. What is the ratio of the Aid received (constant 2012 US$) in Costa Rica in 1991 to that in 1992?
Give a very brief answer. 1.33. What is the ratio of the Aid received (constant 2012 US$) of High income in 1991 to that in 1993?
Make the answer very short. 1.08. What is the ratio of the Aid received (constant 2012 US$) in Aruba in 1991 to that in 1993?
Make the answer very short. 1.06. What is the ratio of the Aid received (constant 2012 US$) of Costa Rica in 1991 to that in 1993?
Your answer should be very brief. 1.76. What is the ratio of the Aid received (constant 2012 US$) in High income in 1992 to that in 1993?
Keep it short and to the point. 1.13. What is the ratio of the Aid received (constant 2012 US$) in Aruba in 1992 to that in 1993?
Offer a very short reply. 1.16. What is the ratio of the Aid received (constant 2012 US$) in Costa Rica in 1992 to that in 1993?
Offer a very short reply. 1.32. What is the difference between the highest and the second highest Aid received (constant 2012 US$) in High income?
Keep it short and to the point. 1.21e+09. What is the difference between the highest and the second highest Aid received (constant 2012 US$) in Aruba?
Make the answer very short. 4.43e+07. What is the difference between the highest and the second highest Aid received (constant 2012 US$) of Costa Rica?
Offer a very short reply. 3.12e+07. What is the difference between the highest and the lowest Aid received (constant 2012 US$) of High income?
Your response must be concise. 2.04e+09. What is the difference between the highest and the lowest Aid received (constant 2012 US$) in Aruba?
Ensure brevity in your answer.  5.84e+07. What is the difference between the highest and the lowest Aid received (constant 2012 US$) of Costa Rica?
Provide a short and direct response. 2.66e+08. 